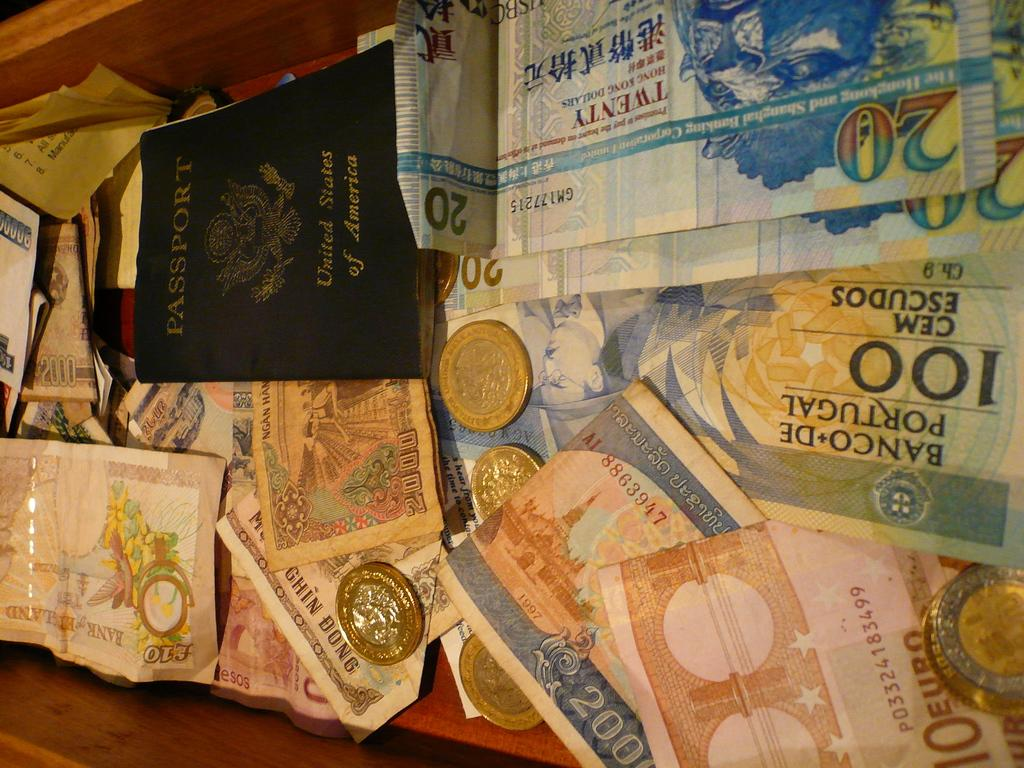<image>
Provide a brief description of the given image. A United States passport sits on top of paper money and coins from different countries. 